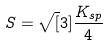Convert formula to latex. <formula><loc_0><loc_0><loc_500><loc_500>S = \sqrt { [ } 3 ] { \frac { K _ { s p } } { 4 } }</formula> 